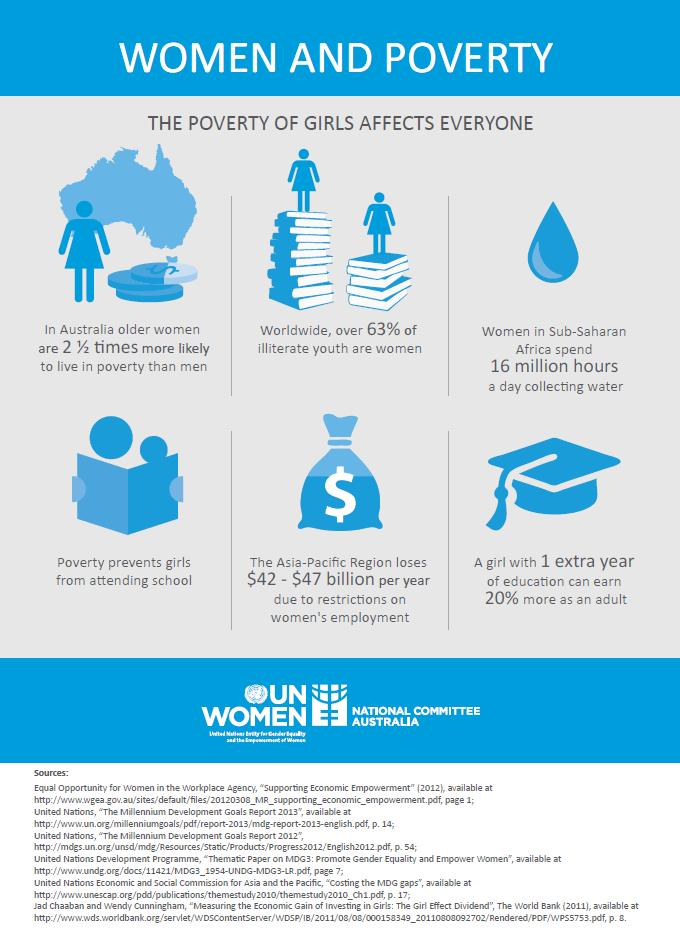Mention a couple of crucial points in this snapshot. The removal of restrictions on women's employment has the potential to save up to $42-$47 billion in revenue each year. The illiteracy rate among women in the age group of youth is 63%. Ensuring at least one additional year of girl education can result in an increased earning potential of 20% as an adult. 